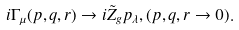<formula> <loc_0><loc_0><loc_500><loc_500>i \Gamma _ { \mu } ( p , q , r ) \to i \tilde { Z } _ { g } p _ { \lambda } , ( p , q , r \to 0 ) .</formula> 